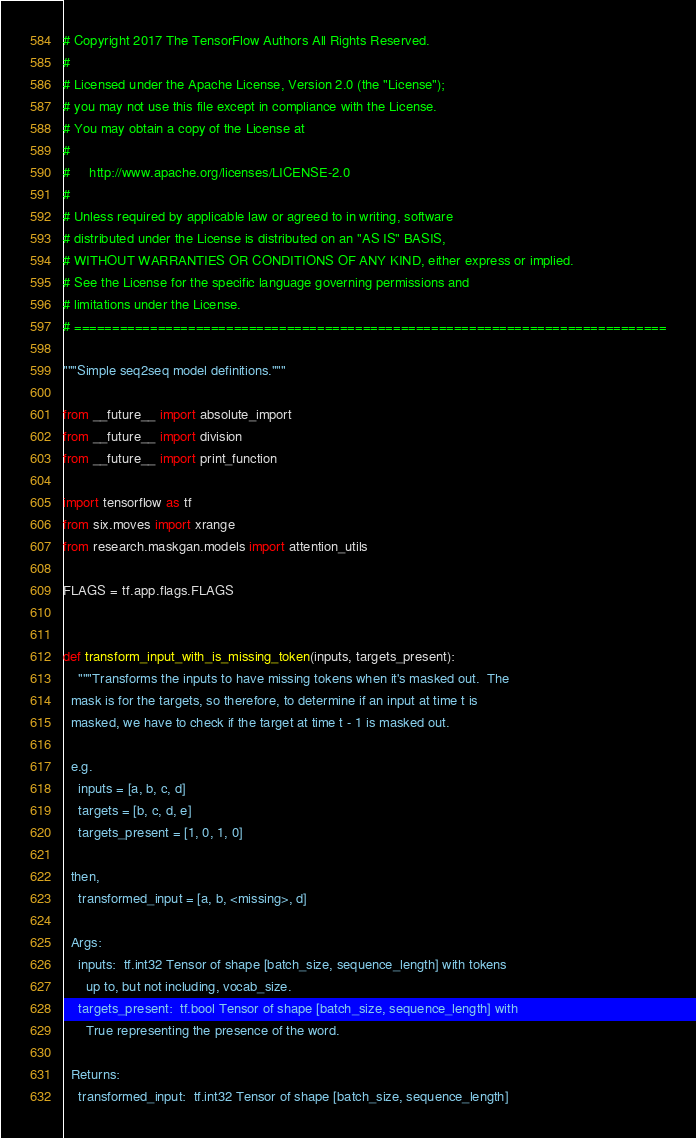Convert code to text. <code><loc_0><loc_0><loc_500><loc_500><_Python_># Copyright 2017 The TensorFlow Authors All Rights Reserved.
#
# Licensed under the Apache License, Version 2.0 (the "License");
# you may not use this file except in compliance with the License.
# You may obtain a copy of the License at
#
#     http://www.apache.org/licenses/LICENSE-2.0
#
# Unless required by applicable law or agreed to in writing, software
# distributed under the License is distributed on an "AS IS" BASIS,
# WITHOUT WARRANTIES OR CONDITIONS OF ANY KIND, either express or implied.
# See the License for the specific language governing permissions and
# limitations under the License.
# ==============================================================================

"""Simple seq2seq model definitions."""

from __future__ import absolute_import
from __future__ import division
from __future__ import print_function

import tensorflow as tf
from six.moves import xrange
from research.maskgan.models import attention_utils

FLAGS = tf.app.flags.FLAGS


def transform_input_with_is_missing_token(inputs, targets_present):
    """Transforms the inputs to have missing tokens when it's masked out.  The
  mask is for the targets, so therefore, to determine if an input at time t is
  masked, we have to check if the target at time t - 1 is masked out.

  e.g.
    inputs = [a, b, c, d]
    targets = [b, c, d, e]
    targets_present = [1, 0, 1, 0]

  then,
    transformed_input = [a, b, <missing>, d]

  Args:
    inputs:  tf.int32 Tensor of shape [batch_size, sequence_length] with tokens
      up to, but not including, vocab_size.
    targets_present:  tf.bool Tensor of shape [batch_size, sequence_length] with
      True representing the presence of the word.

  Returns:
    transformed_input:  tf.int32 Tensor of shape [batch_size, sequence_length]</code> 